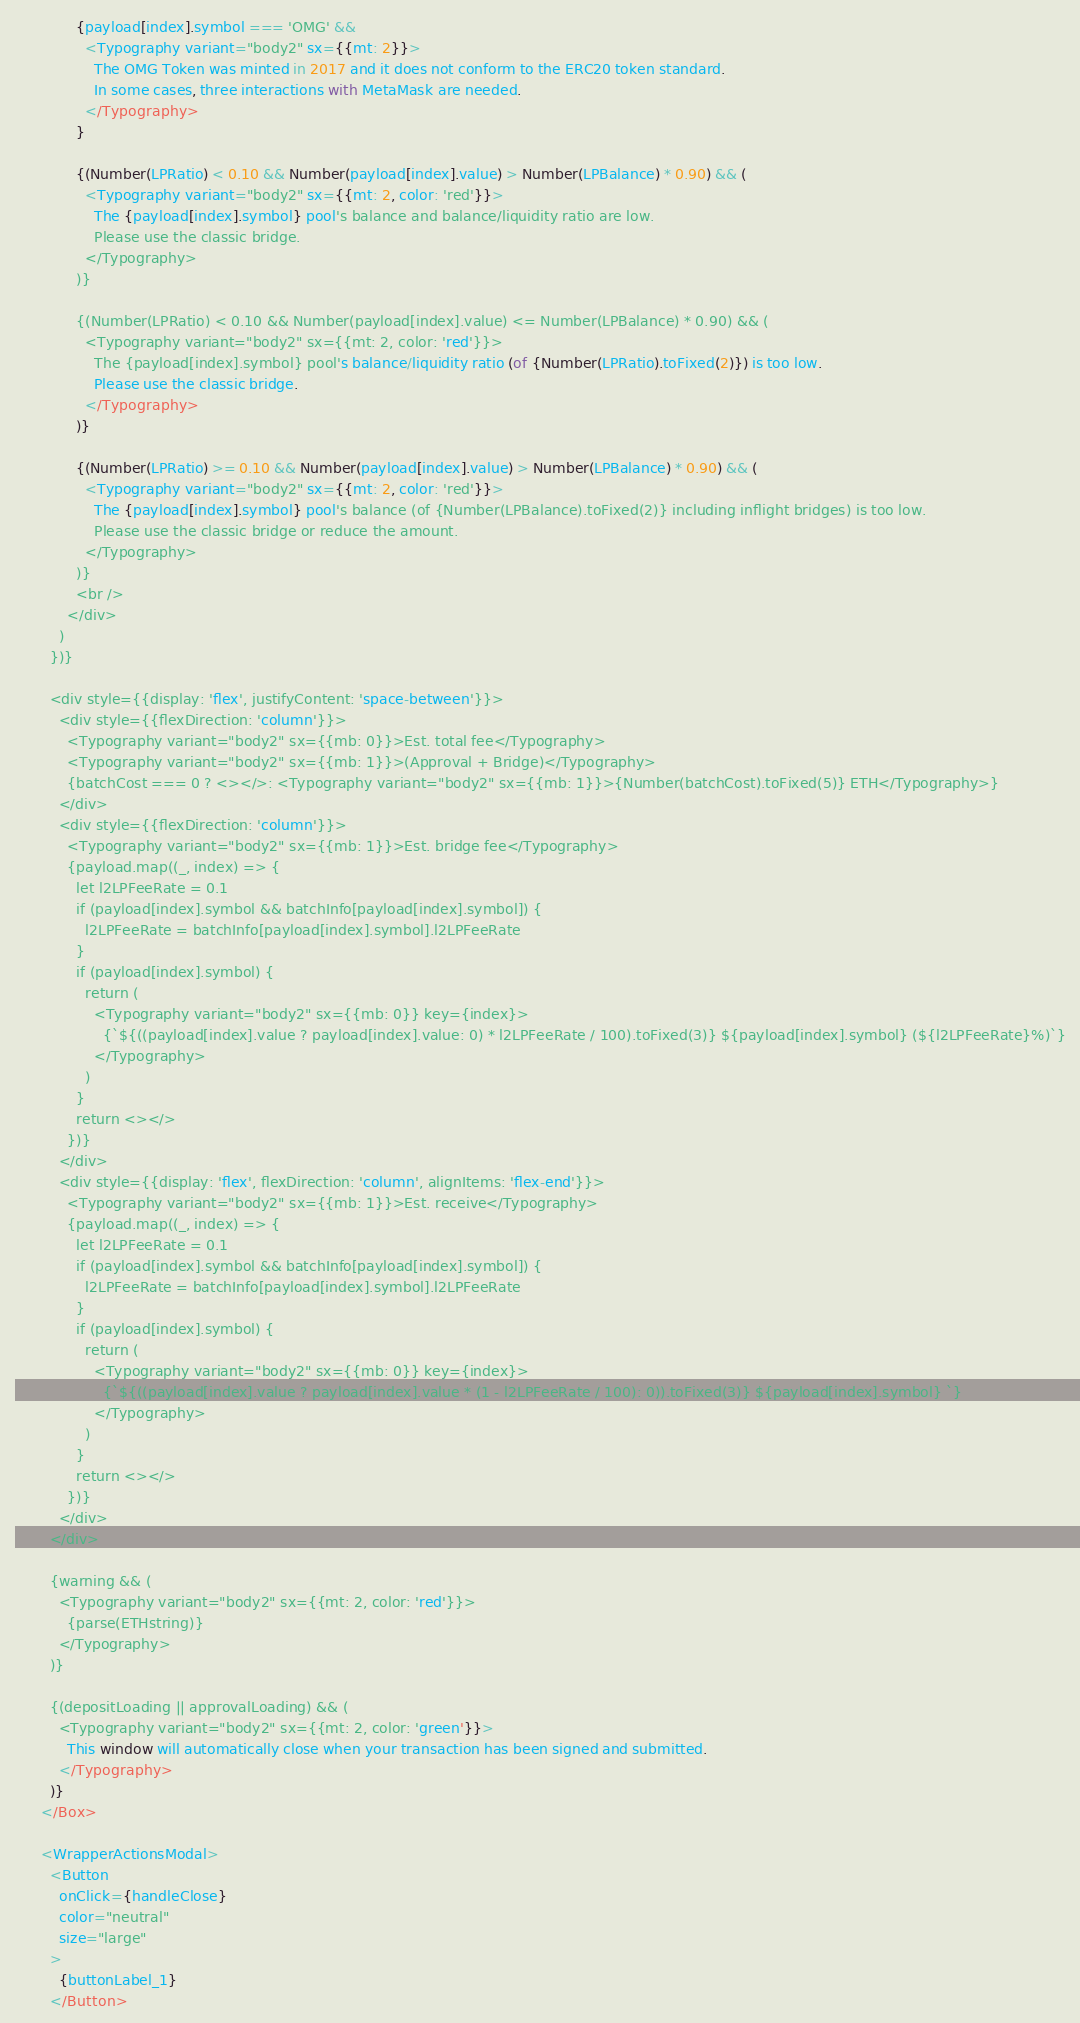Convert code to text. <code><loc_0><loc_0><loc_500><loc_500><_JavaScript_>              {payload[index].symbol === 'OMG' &&
                <Typography variant="body2" sx={{mt: 2}}>
                  The OMG Token was minted in 2017 and it does not conform to the ERC20 token standard.
                  In some cases, three interactions with MetaMask are needed.
                </Typography>
              }

              {(Number(LPRatio) < 0.10 && Number(payload[index].value) > Number(LPBalance) * 0.90) && (
                <Typography variant="body2" sx={{mt: 2, color: 'red'}}>
                  The {payload[index].symbol} pool's balance and balance/liquidity ratio are low.
                  Please use the classic bridge.
                </Typography>
              )}

              {(Number(LPRatio) < 0.10 && Number(payload[index].value) <= Number(LPBalance) * 0.90) && (
                <Typography variant="body2" sx={{mt: 2, color: 'red'}}>
                  The {payload[index].symbol} pool's balance/liquidity ratio (of {Number(LPRatio).toFixed(2)}) is too low.
                  Please use the classic bridge.
                </Typography>
              )}

              {(Number(LPRatio) >= 0.10 && Number(payload[index].value) > Number(LPBalance) * 0.90) && (
                <Typography variant="body2" sx={{mt: 2, color: 'red'}}>
                  The {payload[index].symbol} pool's balance (of {Number(LPBalance).toFixed(2)} including inflight bridges) is too low.
                  Please use the classic bridge or reduce the amount.
                </Typography>
              )}
              <br />
            </div>
          )
        })}

        <div style={{display: 'flex', justifyContent: 'space-between'}}>
          <div style={{flexDirection: 'column'}}>
            <Typography variant="body2" sx={{mb: 0}}>Est. total fee</Typography>
            <Typography variant="body2" sx={{mb: 1}}>(Approval + Bridge)</Typography>
            {batchCost === 0 ? <></>: <Typography variant="body2" sx={{mb: 1}}>{Number(batchCost).toFixed(5)} ETH</Typography>}
          </div>
          <div style={{flexDirection: 'column'}}>
            <Typography variant="body2" sx={{mb: 1}}>Est. bridge fee</Typography>
            {payload.map((_, index) => {
              let l2LPFeeRate = 0.1
              if (payload[index].symbol && batchInfo[payload[index].symbol]) {
                l2LPFeeRate = batchInfo[payload[index].symbol].l2LPFeeRate
              }
              if (payload[index].symbol) {
                return (
                  <Typography variant="body2" sx={{mb: 0}} key={index}>
                    {`${((payload[index].value ? payload[index].value: 0) * l2LPFeeRate / 100).toFixed(3)} ${payload[index].symbol} (${l2LPFeeRate}%)`}
                  </Typography>
                )
              }
              return <></>
            })}
          </div>
          <div style={{display: 'flex', flexDirection: 'column', alignItems: 'flex-end'}}>
            <Typography variant="body2" sx={{mb: 1}}>Est. receive</Typography>
            {payload.map((_, index) => {
              let l2LPFeeRate = 0.1
              if (payload[index].symbol && batchInfo[payload[index].symbol]) {
                l2LPFeeRate = batchInfo[payload[index].symbol].l2LPFeeRate
              }
              if (payload[index].symbol) {
                return (
                  <Typography variant="body2" sx={{mb: 0}} key={index}>
                    {`${((payload[index].value ? payload[index].value * (1 - l2LPFeeRate / 100): 0)).toFixed(3)} ${payload[index].symbol} `}
                  </Typography>
                )
              }
              return <></>
            })}
          </div>
        </div>

        {warning && (
          <Typography variant="body2" sx={{mt: 2, color: 'red'}}>
            {parse(ETHstring)}
          </Typography>
        )}

        {(depositLoading || approvalLoading) && (
          <Typography variant="body2" sx={{mt: 2, color: 'green'}}>
            This window will automatically close when your transaction has been signed and submitted.
          </Typography>
        )}
      </Box>

      <WrapperActionsModal>
        <Button
          onClick={handleClose}
          color="neutral"
          size="large"
        >
          {buttonLabel_1}
        </Button></code> 